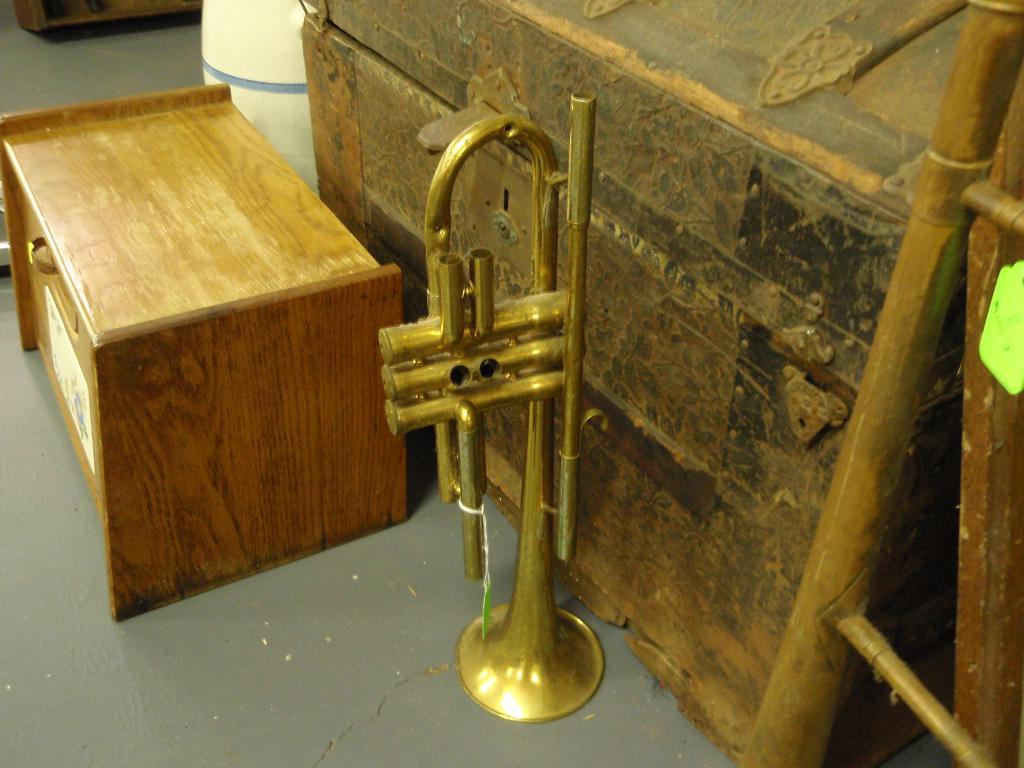What musical instrument is present in the picture? There is a trumpet in the picture. What objects can be seen on the table in the picture? There are wooden boxes on the table in the picture. How much sugar is in the wooden boxes on the table? There is no sugar mentioned or visible in the image; the wooden boxes are empty. 